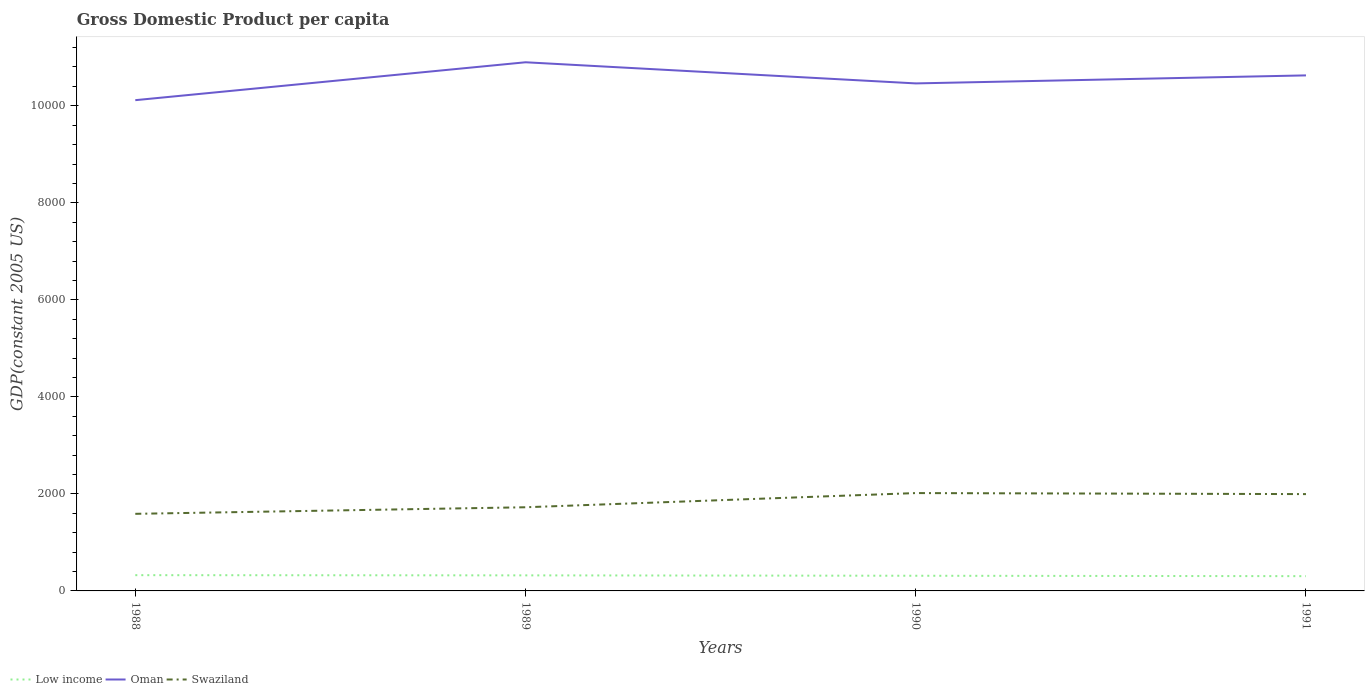How many different coloured lines are there?
Provide a short and direct response. 3. Across all years, what is the maximum GDP per capita in Swaziland?
Keep it short and to the point. 1589.19. In which year was the GDP per capita in Low income maximum?
Your answer should be compact. 1991. What is the total GDP per capita in Swaziland in the graph?
Offer a very short reply. -427.83. What is the difference between the highest and the second highest GDP per capita in Low income?
Your response must be concise. 20.52. What is the difference between the highest and the lowest GDP per capita in Low income?
Offer a very short reply. 2. Is the GDP per capita in Swaziland strictly greater than the GDP per capita in Low income over the years?
Provide a short and direct response. No. How many years are there in the graph?
Your response must be concise. 4. What is the difference between two consecutive major ticks on the Y-axis?
Provide a succinct answer. 2000. Does the graph contain grids?
Make the answer very short. No. What is the title of the graph?
Provide a short and direct response. Gross Domestic Product per capita. What is the label or title of the X-axis?
Make the answer very short. Years. What is the label or title of the Y-axis?
Offer a very short reply. GDP(constant 2005 US). What is the GDP(constant 2005 US) of Low income in 1988?
Give a very brief answer. 324.82. What is the GDP(constant 2005 US) of Oman in 1988?
Ensure brevity in your answer.  1.01e+04. What is the GDP(constant 2005 US) of Swaziland in 1988?
Ensure brevity in your answer.  1589.19. What is the GDP(constant 2005 US) in Low income in 1989?
Make the answer very short. 320.65. What is the GDP(constant 2005 US) in Oman in 1989?
Provide a short and direct response. 1.09e+04. What is the GDP(constant 2005 US) in Swaziland in 1989?
Give a very brief answer. 1724.56. What is the GDP(constant 2005 US) in Low income in 1990?
Provide a succinct answer. 312.79. What is the GDP(constant 2005 US) of Oman in 1990?
Provide a succinct answer. 1.05e+04. What is the GDP(constant 2005 US) in Swaziland in 1990?
Offer a very short reply. 2017.02. What is the GDP(constant 2005 US) of Low income in 1991?
Provide a short and direct response. 304.29. What is the GDP(constant 2005 US) of Oman in 1991?
Your response must be concise. 1.06e+04. What is the GDP(constant 2005 US) in Swaziland in 1991?
Provide a succinct answer. 1995.8. Across all years, what is the maximum GDP(constant 2005 US) of Low income?
Your response must be concise. 324.82. Across all years, what is the maximum GDP(constant 2005 US) of Oman?
Ensure brevity in your answer.  1.09e+04. Across all years, what is the maximum GDP(constant 2005 US) of Swaziland?
Your answer should be compact. 2017.02. Across all years, what is the minimum GDP(constant 2005 US) in Low income?
Make the answer very short. 304.29. Across all years, what is the minimum GDP(constant 2005 US) in Oman?
Make the answer very short. 1.01e+04. Across all years, what is the minimum GDP(constant 2005 US) of Swaziland?
Provide a short and direct response. 1589.19. What is the total GDP(constant 2005 US) in Low income in the graph?
Give a very brief answer. 1262.55. What is the total GDP(constant 2005 US) in Oman in the graph?
Offer a very short reply. 4.21e+04. What is the total GDP(constant 2005 US) in Swaziland in the graph?
Your answer should be very brief. 7326.58. What is the difference between the GDP(constant 2005 US) of Low income in 1988 and that in 1989?
Provide a short and direct response. 4.16. What is the difference between the GDP(constant 2005 US) in Oman in 1988 and that in 1989?
Your response must be concise. -781.26. What is the difference between the GDP(constant 2005 US) of Swaziland in 1988 and that in 1989?
Give a very brief answer. -135.38. What is the difference between the GDP(constant 2005 US) of Low income in 1988 and that in 1990?
Offer a very short reply. 12.03. What is the difference between the GDP(constant 2005 US) in Oman in 1988 and that in 1990?
Ensure brevity in your answer.  -345.49. What is the difference between the GDP(constant 2005 US) of Swaziland in 1988 and that in 1990?
Make the answer very short. -427.83. What is the difference between the GDP(constant 2005 US) in Low income in 1988 and that in 1991?
Offer a terse response. 20.52. What is the difference between the GDP(constant 2005 US) in Oman in 1988 and that in 1991?
Your answer should be very brief. -510.71. What is the difference between the GDP(constant 2005 US) in Swaziland in 1988 and that in 1991?
Your response must be concise. -406.62. What is the difference between the GDP(constant 2005 US) of Low income in 1989 and that in 1990?
Offer a terse response. 7.86. What is the difference between the GDP(constant 2005 US) of Oman in 1989 and that in 1990?
Provide a succinct answer. 435.77. What is the difference between the GDP(constant 2005 US) of Swaziland in 1989 and that in 1990?
Provide a short and direct response. -292.46. What is the difference between the GDP(constant 2005 US) of Low income in 1989 and that in 1991?
Your answer should be very brief. 16.36. What is the difference between the GDP(constant 2005 US) in Oman in 1989 and that in 1991?
Keep it short and to the point. 270.55. What is the difference between the GDP(constant 2005 US) in Swaziland in 1989 and that in 1991?
Make the answer very short. -271.24. What is the difference between the GDP(constant 2005 US) of Low income in 1990 and that in 1991?
Ensure brevity in your answer.  8.5. What is the difference between the GDP(constant 2005 US) of Oman in 1990 and that in 1991?
Provide a succinct answer. -165.22. What is the difference between the GDP(constant 2005 US) in Swaziland in 1990 and that in 1991?
Your response must be concise. 21.22. What is the difference between the GDP(constant 2005 US) of Low income in 1988 and the GDP(constant 2005 US) of Oman in 1989?
Ensure brevity in your answer.  -1.06e+04. What is the difference between the GDP(constant 2005 US) of Low income in 1988 and the GDP(constant 2005 US) of Swaziland in 1989?
Your answer should be compact. -1399.75. What is the difference between the GDP(constant 2005 US) in Oman in 1988 and the GDP(constant 2005 US) in Swaziland in 1989?
Your response must be concise. 8391.42. What is the difference between the GDP(constant 2005 US) in Low income in 1988 and the GDP(constant 2005 US) in Oman in 1990?
Provide a short and direct response. -1.01e+04. What is the difference between the GDP(constant 2005 US) of Low income in 1988 and the GDP(constant 2005 US) of Swaziland in 1990?
Give a very brief answer. -1692.21. What is the difference between the GDP(constant 2005 US) in Oman in 1988 and the GDP(constant 2005 US) in Swaziland in 1990?
Give a very brief answer. 8098.97. What is the difference between the GDP(constant 2005 US) of Low income in 1988 and the GDP(constant 2005 US) of Oman in 1991?
Provide a short and direct response. -1.03e+04. What is the difference between the GDP(constant 2005 US) of Low income in 1988 and the GDP(constant 2005 US) of Swaziland in 1991?
Provide a succinct answer. -1670.99. What is the difference between the GDP(constant 2005 US) in Oman in 1988 and the GDP(constant 2005 US) in Swaziland in 1991?
Give a very brief answer. 8120.18. What is the difference between the GDP(constant 2005 US) of Low income in 1989 and the GDP(constant 2005 US) of Oman in 1990?
Offer a terse response. -1.01e+04. What is the difference between the GDP(constant 2005 US) of Low income in 1989 and the GDP(constant 2005 US) of Swaziland in 1990?
Your answer should be compact. -1696.37. What is the difference between the GDP(constant 2005 US) of Oman in 1989 and the GDP(constant 2005 US) of Swaziland in 1990?
Your answer should be compact. 8880.23. What is the difference between the GDP(constant 2005 US) of Low income in 1989 and the GDP(constant 2005 US) of Oman in 1991?
Your answer should be compact. -1.03e+04. What is the difference between the GDP(constant 2005 US) of Low income in 1989 and the GDP(constant 2005 US) of Swaziland in 1991?
Provide a succinct answer. -1675.15. What is the difference between the GDP(constant 2005 US) in Oman in 1989 and the GDP(constant 2005 US) in Swaziland in 1991?
Offer a terse response. 8901.44. What is the difference between the GDP(constant 2005 US) in Low income in 1990 and the GDP(constant 2005 US) in Oman in 1991?
Give a very brief answer. -1.03e+04. What is the difference between the GDP(constant 2005 US) in Low income in 1990 and the GDP(constant 2005 US) in Swaziland in 1991?
Ensure brevity in your answer.  -1683.02. What is the difference between the GDP(constant 2005 US) in Oman in 1990 and the GDP(constant 2005 US) in Swaziland in 1991?
Your answer should be very brief. 8465.68. What is the average GDP(constant 2005 US) of Low income per year?
Your response must be concise. 315.64. What is the average GDP(constant 2005 US) of Oman per year?
Your answer should be very brief. 1.05e+04. What is the average GDP(constant 2005 US) in Swaziland per year?
Offer a very short reply. 1831.64. In the year 1988, what is the difference between the GDP(constant 2005 US) of Low income and GDP(constant 2005 US) of Oman?
Provide a short and direct response. -9791.17. In the year 1988, what is the difference between the GDP(constant 2005 US) of Low income and GDP(constant 2005 US) of Swaziland?
Provide a succinct answer. -1264.37. In the year 1988, what is the difference between the GDP(constant 2005 US) of Oman and GDP(constant 2005 US) of Swaziland?
Your answer should be compact. 8526.8. In the year 1989, what is the difference between the GDP(constant 2005 US) in Low income and GDP(constant 2005 US) in Oman?
Offer a terse response. -1.06e+04. In the year 1989, what is the difference between the GDP(constant 2005 US) in Low income and GDP(constant 2005 US) in Swaziland?
Offer a very short reply. -1403.91. In the year 1989, what is the difference between the GDP(constant 2005 US) of Oman and GDP(constant 2005 US) of Swaziland?
Keep it short and to the point. 9172.68. In the year 1990, what is the difference between the GDP(constant 2005 US) in Low income and GDP(constant 2005 US) in Oman?
Provide a succinct answer. -1.01e+04. In the year 1990, what is the difference between the GDP(constant 2005 US) of Low income and GDP(constant 2005 US) of Swaziland?
Your answer should be very brief. -1704.23. In the year 1990, what is the difference between the GDP(constant 2005 US) of Oman and GDP(constant 2005 US) of Swaziland?
Provide a succinct answer. 8444.46. In the year 1991, what is the difference between the GDP(constant 2005 US) of Low income and GDP(constant 2005 US) of Oman?
Keep it short and to the point. -1.03e+04. In the year 1991, what is the difference between the GDP(constant 2005 US) of Low income and GDP(constant 2005 US) of Swaziland?
Make the answer very short. -1691.51. In the year 1991, what is the difference between the GDP(constant 2005 US) of Oman and GDP(constant 2005 US) of Swaziland?
Your response must be concise. 8630.89. What is the ratio of the GDP(constant 2005 US) in Low income in 1988 to that in 1989?
Provide a succinct answer. 1.01. What is the ratio of the GDP(constant 2005 US) in Oman in 1988 to that in 1989?
Your answer should be very brief. 0.93. What is the ratio of the GDP(constant 2005 US) in Swaziland in 1988 to that in 1989?
Give a very brief answer. 0.92. What is the ratio of the GDP(constant 2005 US) of Swaziland in 1988 to that in 1990?
Give a very brief answer. 0.79. What is the ratio of the GDP(constant 2005 US) in Low income in 1988 to that in 1991?
Give a very brief answer. 1.07. What is the ratio of the GDP(constant 2005 US) of Oman in 1988 to that in 1991?
Offer a very short reply. 0.95. What is the ratio of the GDP(constant 2005 US) in Swaziland in 1988 to that in 1991?
Provide a succinct answer. 0.8. What is the ratio of the GDP(constant 2005 US) in Low income in 1989 to that in 1990?
Give a very brief answer. 1.03. What is the ratio of the GDP(constant 2005 US) of Oman in 1989 to that in 1990?
Offer a very short reply. 1.04. What is the ratio of the GDP(constant 2005 US) of Swaziland in 1989 to that in 1990?
Ensure brevity in your answer.  0.85. What is the ratio of the GDP(constant 2005 US) of Low income in 1989 to that in 1991?
Make the answer very short. 1.05. What is the ratio of the GDP(constant 2005 US) in Oman in 1989 to that in 1991?
Offer a terse response. 1.03. What is the ratio of the GDP(constant 2005 US) in Swaziland in 1989 to that in 1991?
Offer a terse response. 0.86. What is the ratio of the GDP(constant 2005 US) in Low income in 1990 to that in 1991?
Make the answer very short. 1.03. What is the ratio of the GDP(constant 2005 US) of Oman in 1990 to that in 1991?
Give a very brief answer. 0.98. What is the ratio of the GDP(constant 2005 US) of Swaziland in 1990 to that in 1991?
Your answer should be very brief. 1.01. What is the difference between the highest and the second highest GDP(constant 2005 US) of Low income?
Provide a succinct answer. 4.16. What is the difference between the highest and the second highest GDP(constant 2005 US) in Oman?
Keep it short and to the point. 270.55. What is the difference between the highest and the second highest GDP(constant 2005 US) of Swaziland?
Offer a terse response. 21.22. What is the difference between the highest and the lowest GDP(constant 2005 US) of Low income?
Keep it short and to the point. 20.52. What is the difference between the highest and the lowest GDP(constant 2005 US) in Oman?
Your response must be concise. 781.26. What is the difference between the highest and the lowest GDP(constant 2005 US) in Swaziland?
Make the answer very short. 427.83. 